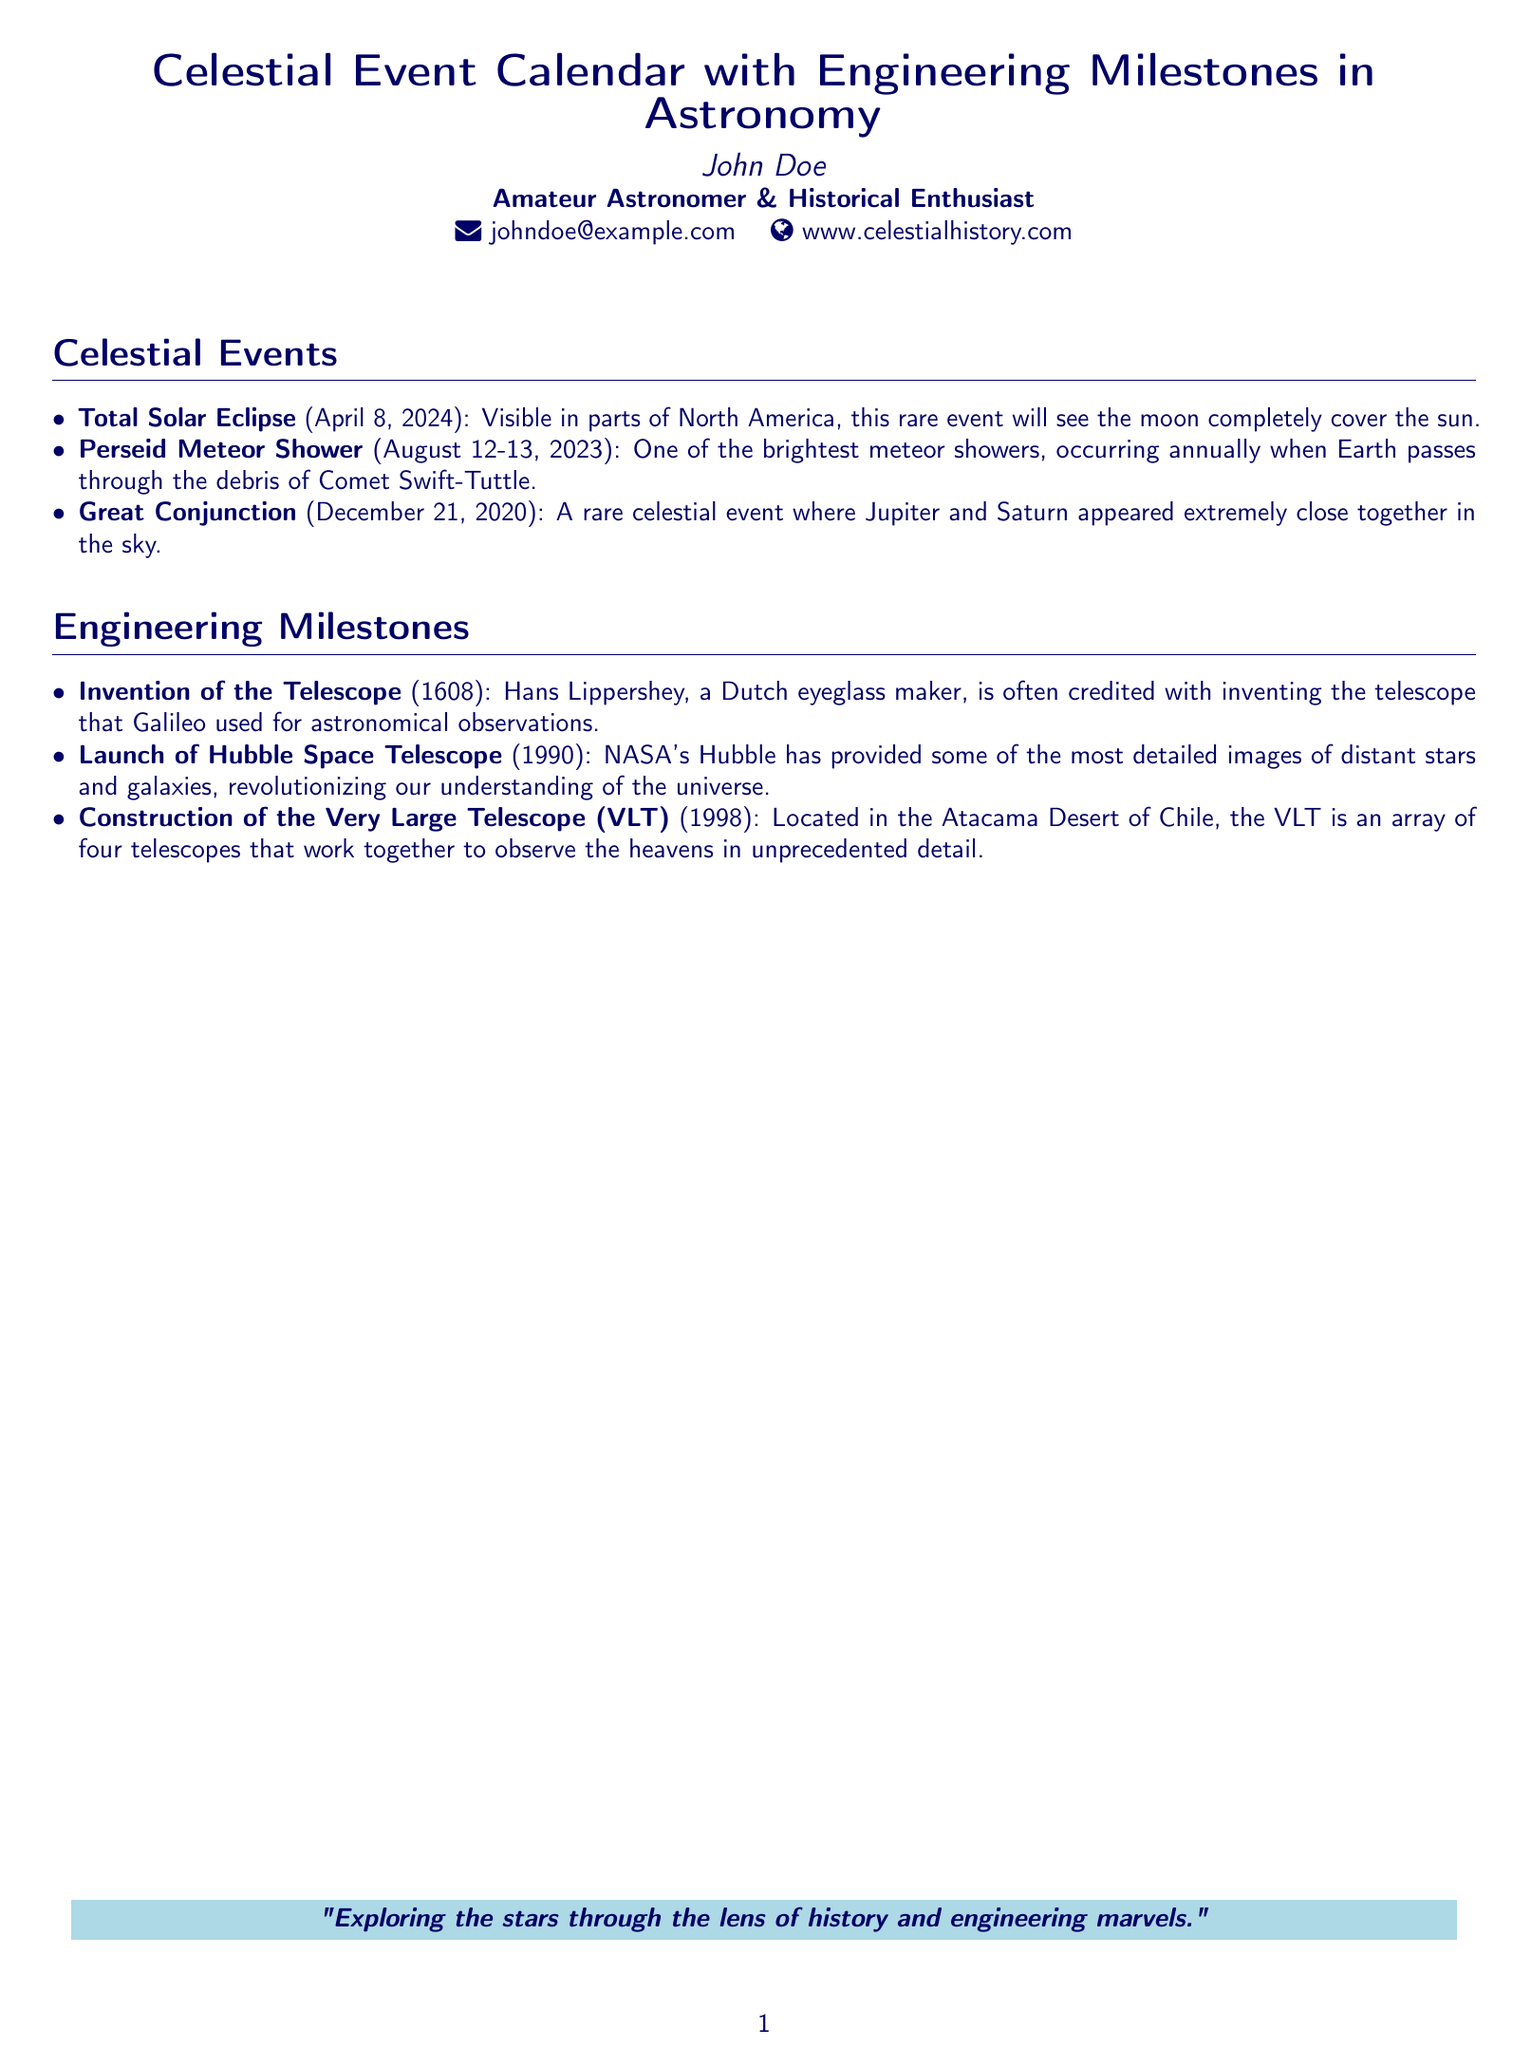What is the date of the Total Solar Eclipse? The Total Solar Eclipse is scheduled for April 8, 2024.
Answer: April 8, 2024 Who invented the telescope? The telescope is often credited to Hans Lippershey, a Dutch eyeglass maker.
Answer: Hans Lippershey What major celestial event occurred on December 21, 2020? The Great Conjunction occurred when Jupiter and Saturn appeared extremely close together.
Answer: Great Conjunction In what year was the Hubble Space Telescope launched? The Hubble Space Telescope was launched in 1990.
Answer: 1990 What is the location of the Very Large Telescope? The Very Large Telescope is located in the Atacama Desert of Chile.
Answer: Atacama Desert Which meteor shower is mentioned in the document? The document lists the Perseid Meteor Shower as one of the events.
Answer: Perseid Meteor Shower What is the main theme of the document? The document combines celestial events with engineering milestones in astronomy.
Answer: Celestial Events and Engineering Milestones Who is the author of the business card? The author of the business card is John Doe.
Answer: John Doe 